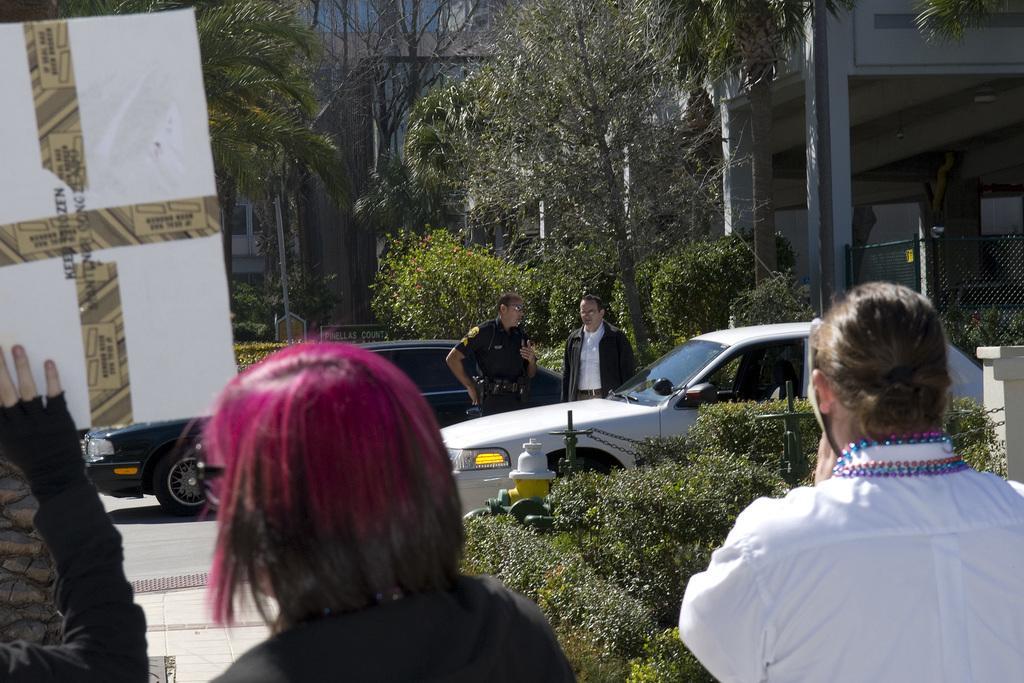Describe this image in one or two sentences. In this image I can see two persons, the person at right wearing white color shirt. Background I can see two vehicles, one is in black color and the other is in white color. I can see two persons standing and trees in green color. 